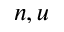Convert formula to latex. <formula><loc_0><loc_0><loc_500><loc_500>n , u</formula> 